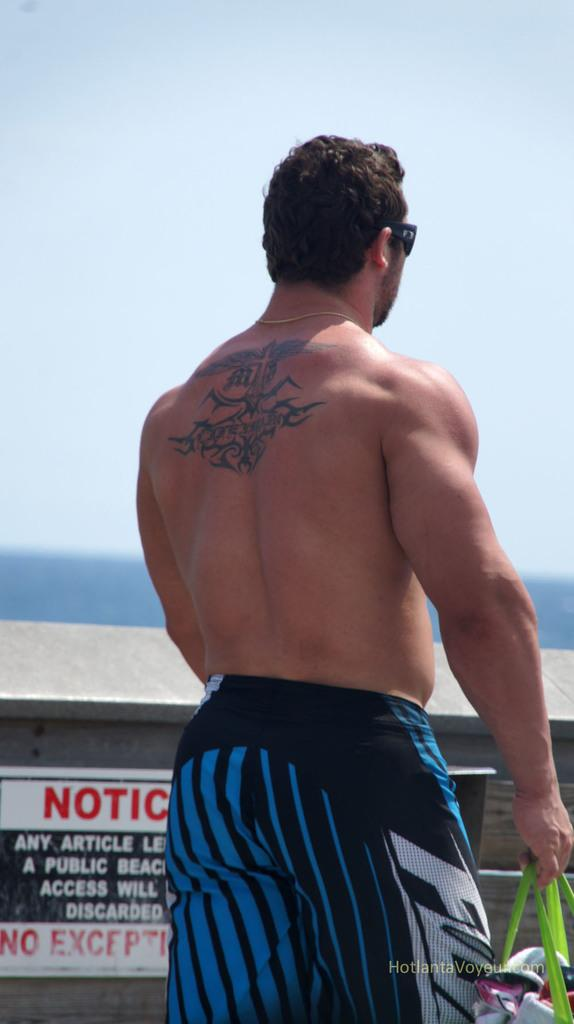<image>
Share a concise interpretation of the image provided. A man in swim trucks with a tattoo on his back is walking past a sign that says Notice. 